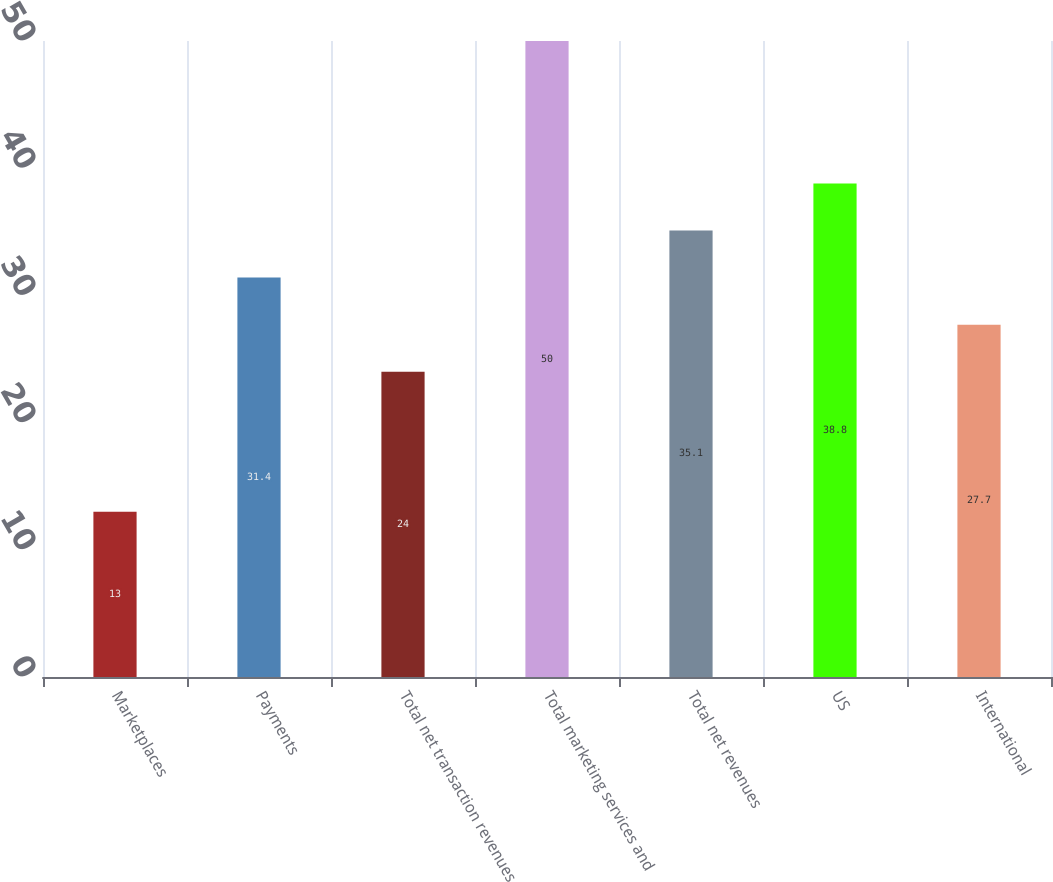Convert chart to OTSL. <chart><loc_0><loc_0><loc_500><loc_500><bar_chart><fcel>Marketplaces<fcel>Payments<fcel>Total net transaction revenues<fcel>Total marketing services and<fcel>Total net revenues<fcel>US<fcel>International<nl><fcel>13<fcel>31.4<fcel>24<fcel>50<fcel>35.1<fcel>38.8<fcel>27.7<nl></chart> 